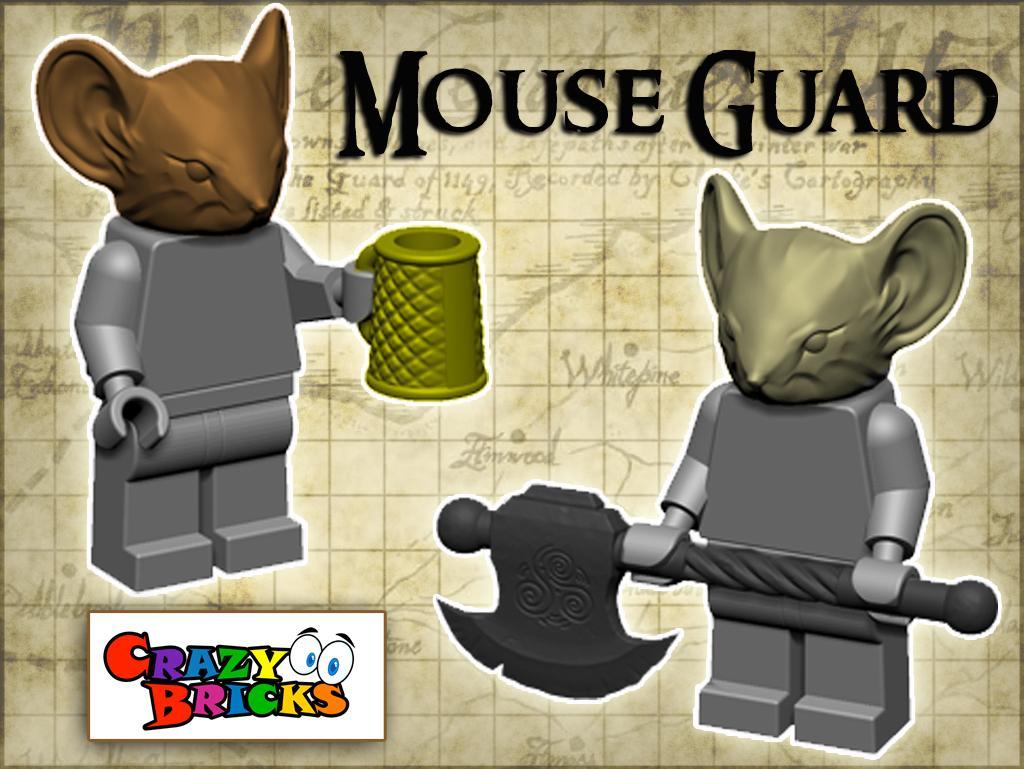Could you give a brief overview of what you see in this image? In the picture we can see animated images of mouse holding cup and weapon in their hands and there are some words written. 